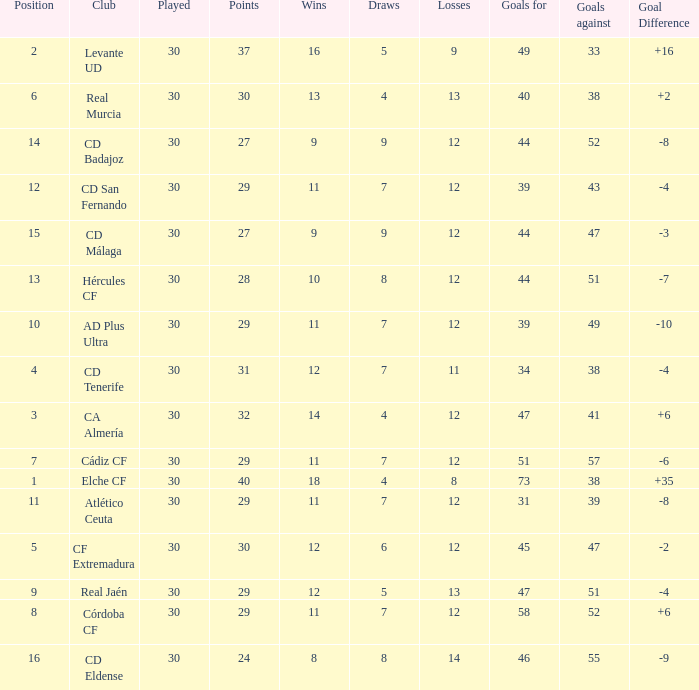What is the sum of the goals with less than 30 points, a position less than 10, and more than 57 goals against? None. 